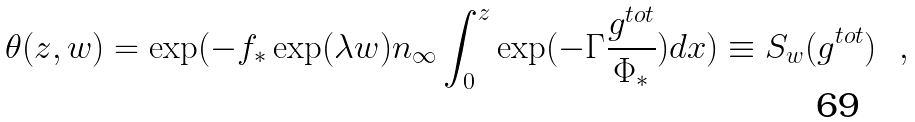Convert formula to latex. <formula><loc_0><loc_0><loc_500><loc_500>\theta ( z , w ) = \exp ( - f _ { * } \exp ( \lambda w ) n _ { \infty } \int _ { 0 } ^ { z } \exp ( - \Gamma \frac { g ^ { t o t } } { \Phi _ { * } } ) d x ) \equiv S _ { w } ( g ^ { t o t } ) \ \ ,</formula> 